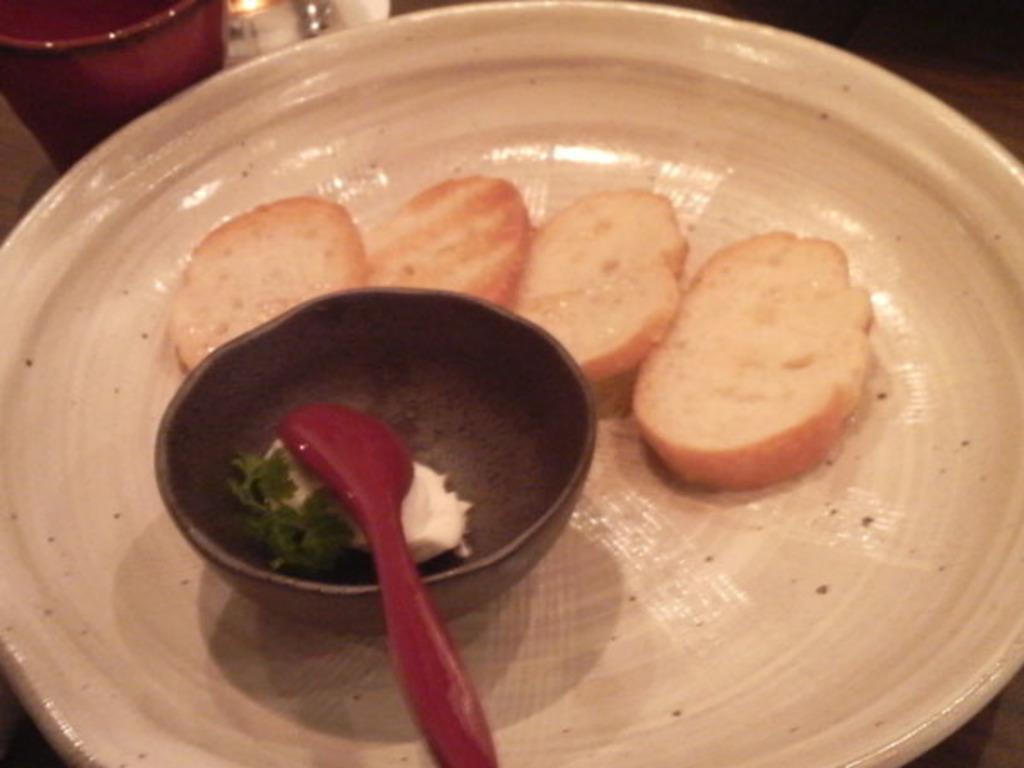Describe this image in one or two sentences. In this image I can see a plate and in the plate I can see a food item which is cream and brown in color. I can see a bowl and a spoon. I can see few other objects. 